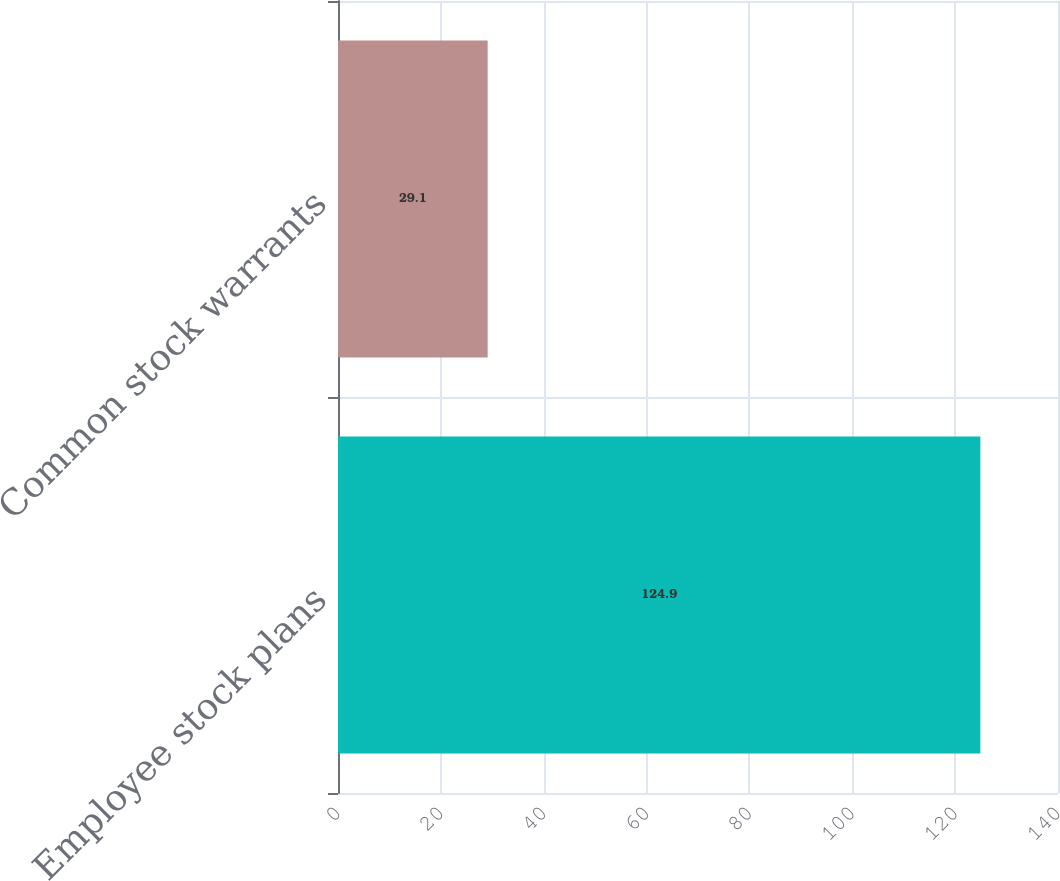Convert chart to OTSL. <chart><loc_0><loc_0><loc_500><loc_500><bar_chart><fcel>Employee stock plans<fcel>Common stock warrants<nl><fcel>124.9<fcel>29.1<nl></chart> 